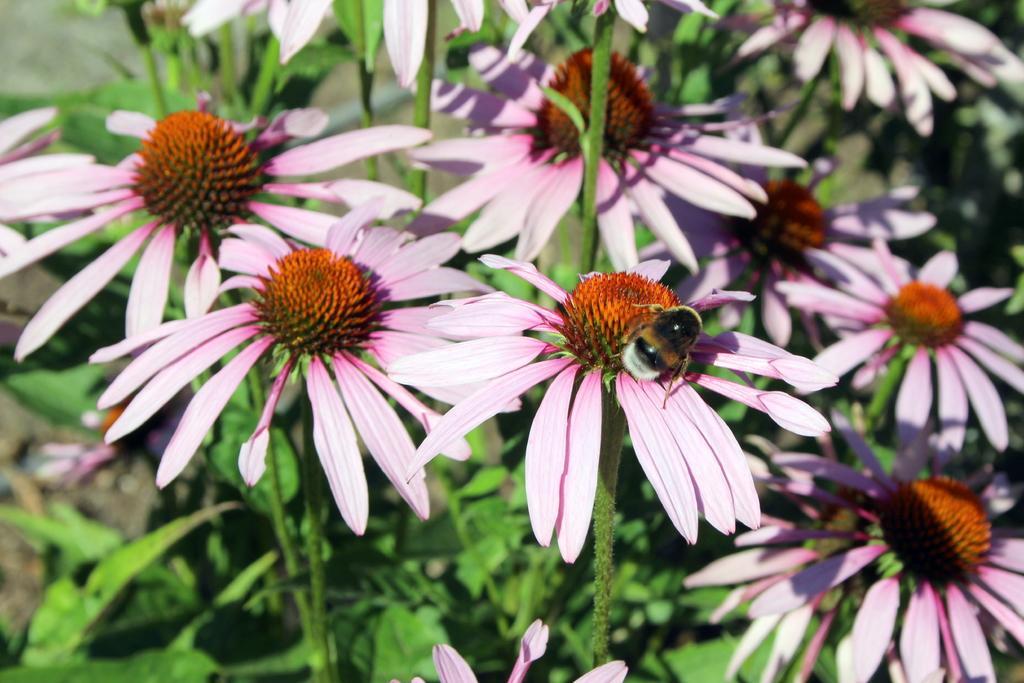Can you describe this image briefly? In this image I can see the flowers. I can see an insect. 